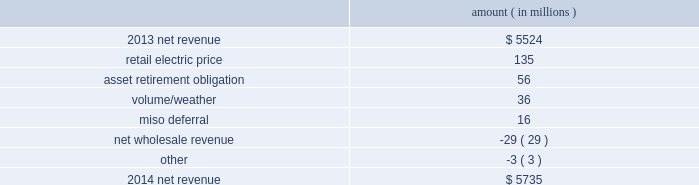Entergy corporation and subsidiaries management 2019s financial discussion and analysis net revenue utility following is an analysis of the change in net revenue comparing 2014 to 2013 .
Amount ( in millions ) .
The retail electric price variance is primarily due to : 2022 increases in the energy efficiency rider at entergy arkansas , as approved by the apsc , effective july 2013 and july 2014 .
Energy efficiency revenues are offset by costs included in other operation and maintenance expenses and have minimal effect on net income ; 2022 the effect of the apsc 2019s order in entergy arkansas 2019s 2013 rate case , including an annual base rate increase effective january 2014 offset by a miso rider to provide customers credits in rates for transmission revenue received through miso ; 2022 a formula rate plan increase at entergy mississippi , as approved by the mspc , effective september 2013 ; 2022 an increase in entergy mississippi 2019s storm damage rider , as approved by the mpsc , effective october 2013 .
The increase in the storm damage rider is offset by other operation and maintenance expenses and has no effect on net income ; 2022 an annual base rate increase at entergy texas , effective april 2014 , as a result of the puct 2019s order in the september 2013 rate case ; and 2022 a formula rate plan increase at entergy louisiana , as approved by the lpsc , effective december 2014 .
See note 2 to the financial statements for a discussion of rate proceedings .
The asset retirement obligation affects net revenue because entergy records a regulatory debit or credit for the difference between asset retirement obligation-related expenses and trust earnings plus asset retirement obligation- related costs collected in revenue .
The variance is primarily caused by increases in regulatory credits because of decreases in decommissioning trust earnings and increases in depreciation and accretion expenses and increases in regulatory credits to realign the asset retirement obligation regulatory assets with regulatory treatment .
The volume/weather variance is primarily due to an increase of 3129 gwh , or 3% ( 3 % ) , in billed electricity usage primarily due to an increase in sales to industrial customers and the effect of more favorable weather on residential sales .
The increase in industrial sales was primarily due to expansions , recovery of a major refining customer from an unplanned outage in 2013 , and continued moderate growth in the manufacturing sector .
The miso deferral variance is primarily due to the deferral in 2014 of the non-fuel miso-related charges , as approved by the lpsc and the mpsc , partially offset by the deferral in april 2013 , as approved by the apsc , of costs incurred from march 2010 through december 2012 related to the transition and implementation of joining the miso .
What is the retail electric price as a percentage of net revenue in 2013? 
Computations: (135 / 5524)
Answer: 0.02444. 